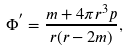<formula> <loc_0><loc_0><loc_500><loc_500>\Phi ^ { ^ { \prime } } = \frac { m + 4 \pi r ^ { 3 } p } { r ( r - 2 m ) } ,</formula> 